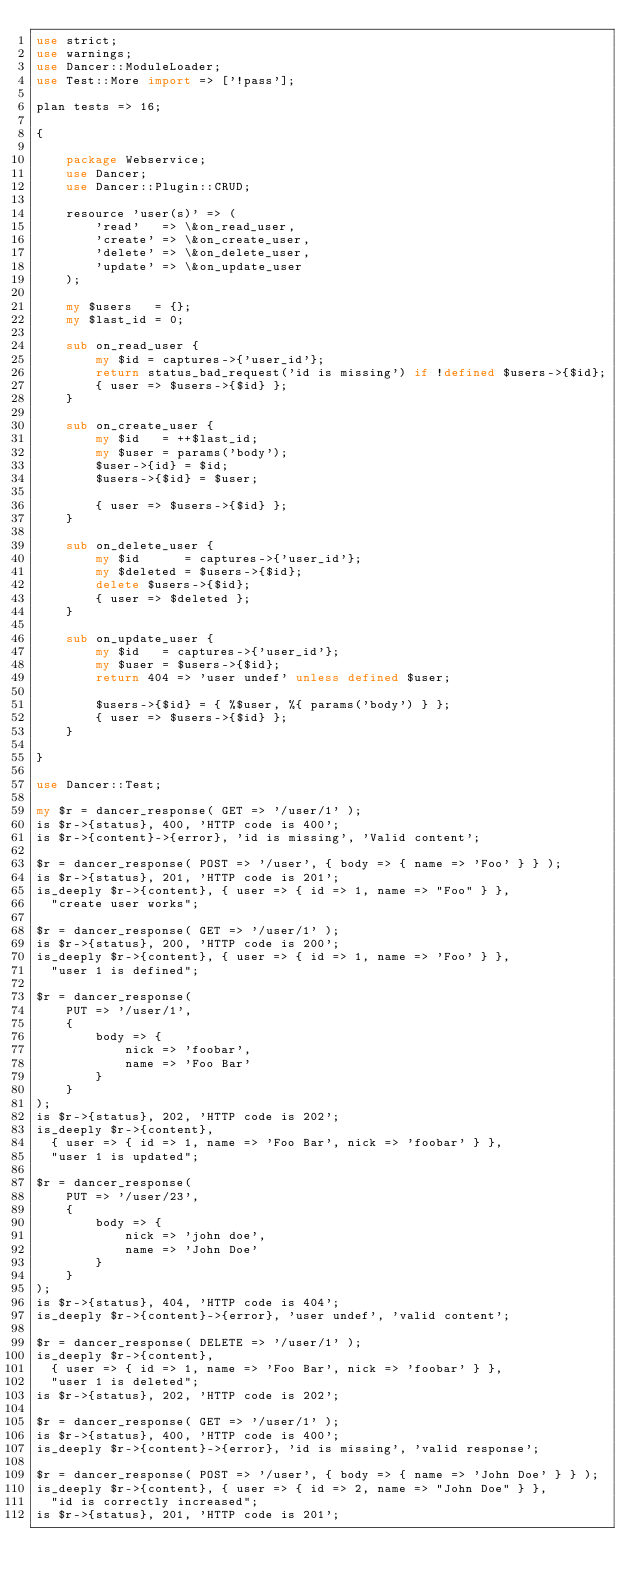<code> <loc_0><loc_0><loc_500><loc_500><_Perl_>use strict;
use warnings;
use Dancer::ModuleLoader;
use Test::More import => ['!pass'];

plan tests => 16;

{

    package Webservice;
    use Dancer;
    use Dancer::Plugin::CRUD;

    resource 'user(s)' => (
        'read'   => \&on_read_user,
        'create' => \&on_create_user,
        'delete' => \&on_delete_user,
        'update' => \&on_update_user
    );

    my $users   = {};
    my $last_id = 0;

    sub on_read_user {
        my $id = captures->{'user_id'};
        return status_bad_request('id is missing') if !defined $users->{$id};
        { user => $users->{$id} };
    }

    sub on_create_user {
        my $id   = ++$last_id;
        my $user = params('body');
        $user->{id} = $id;
        $users->{$id} = $user;

        { user => $users->{$id} };
    }

    sub on_delete_user {
        my $id      = captures->{'user_id'};
        my $deleted = $users->{$id};
        delete $users->{$id};
        { user => $deleted };
    }

    sub on_update_user {
        my $id   = captures->{'user_id'};
        my $user = $users->{$id};
        return 404 => 'user undef' unless defined $user;

        $users->{$id} = { %$user, %{ params('body') } };
        { user => $users->{$id} };
    }

}

use Dancer::Test;

my $r = dancer_response( GET => '/user/1' );
is $r->{status}, 400, 'HTTP code is 400';
is $r->{content}->{error}, 'id is missing', 'Valid content';

$r = dancer_response( POST => '/user', { body => { name => 'Foo' } } );
is $r->{status}, 201, 'HTTP code is 201';
is_deeply $r->{content}, { user => { id => 1, name => "Foo" } },
  "create user works";

$r = dancer_response( GET => '/user/1' );
is $r->{status}, 200, 'HTTP code is 200';
is_deeply $r->{content}, { user => { id => 1, name => 'Foo' } },
  "user 1 is defined";

$r = dancer_response(
    PUT => '/user/1',
    {
        body => {
            nick => 'foobar',
            name => 'Foo Bar'
        }
    }
);
is $r->{status}, 202, 'HTTP code is 202';
is_deeply $r->{content},
  { user => { id => 1, name => 'Foo Bar', nick => 'foobar' } },
  "user 1 is updated";

$r = dancer_response(
    PUT => '/user/23',
    {
        body => {
            nick => 'john doe',
            name => 'John Doe'
        }
    }
);
is $r->{status}, 404, 'HTTP code is 404';
is_deeply $r->{content}->{error}, 'user undef', 'valid content';

$r = dancer_response( DELETE => '/user/1' );
is_deeply $r->{content},
  { user => { id => 1, name => 'Foo Bar', nick => 'foobar' } },
  "user 1 is deleted";
is $r->{status}, 202, 'HTTP code is 202';

$r = dancer_response( GET => '/user/1' );
is $r->{status}, 400, 'HTTP code is 400';
is_deeply $r->{content}->{error}, 'id is missing', 'valid response';

$r = dancer_response( POST => '/user', { body => { name => 'John Doe' } } );
is_deeply $r->{content}, { user => { id => 2, name => "John Doe" } },
  "id is correctly increased";
is $r->{status}, 201, 'HTTP code is 201';

</code> 